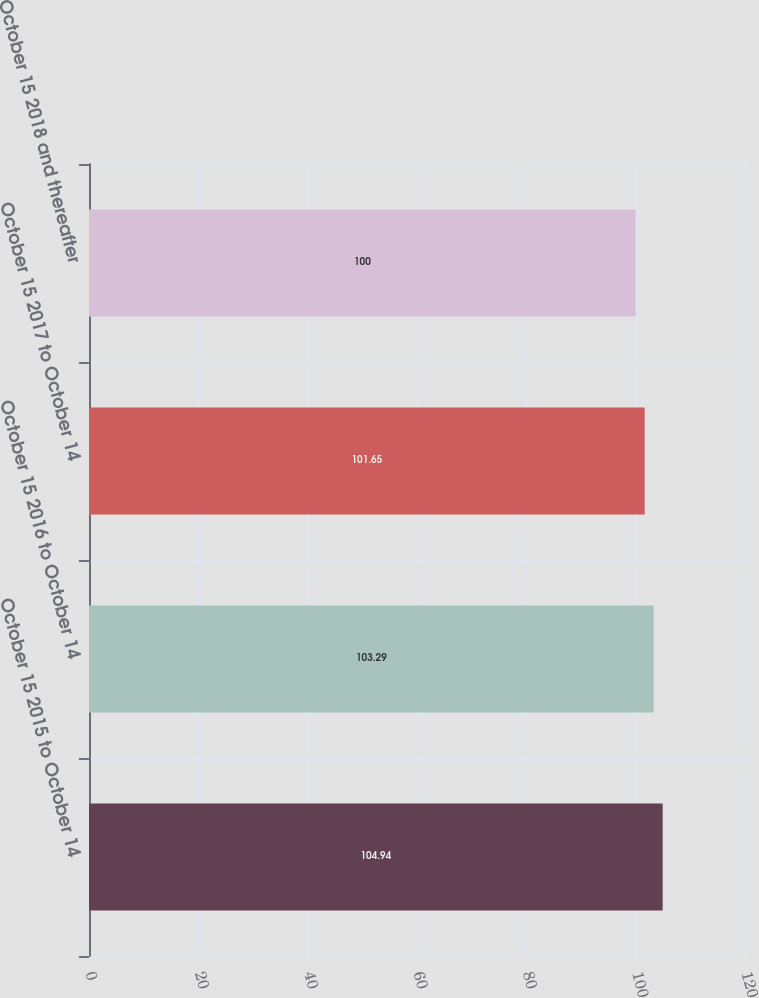Convert chart to OTSL. <chart><loc_0><loc_0><loc_500><loc_500><bar_chart><fcel>October 15 2015 to October 14<fcel>October 15 2016 to October 14<fcel>October 15 2017 to October 14<fcel>October 15 2018 and thereafter<nl><fcel>104.94<fcel>103.29<fcel>101.65<fcel>100<nl></chart> 